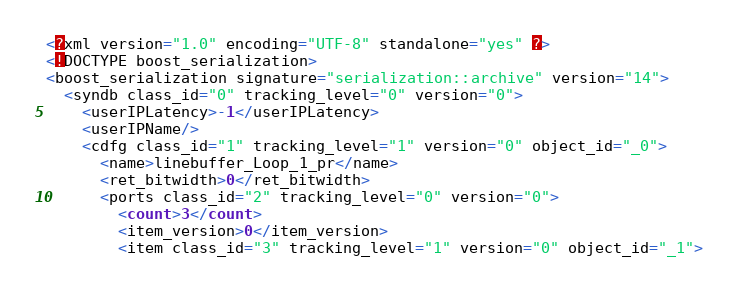Convert code to text. <code><loc_0><loc_0><loc_500><loc_500><_Ada_><?xml version="1.0" encoding="UTF-8" standalone="yes" ?>
<!DOCTYPE boost_serialization>
<boost_serialization signature="serialization::archive" version="14">
  <syndb class_id="0" tracking_level="0" version="0">
    <userIPLatency>-1</userIPLatency>
    <userIPName/>
    <cdfg class_id="1" tracking_level="1" version="0" object_id="_0">
      <name>linebuffer_Loop_1_pr</name>
      <ret_bitwidth>0</ret_bitwidth>
      <ports class_id="2" tracking_level="0" version="0">
        <count>3</count>
        <item_version>0</item_version>
        <item class_id="3" tracking_level="1" version="0" object_id="_1"></code> 